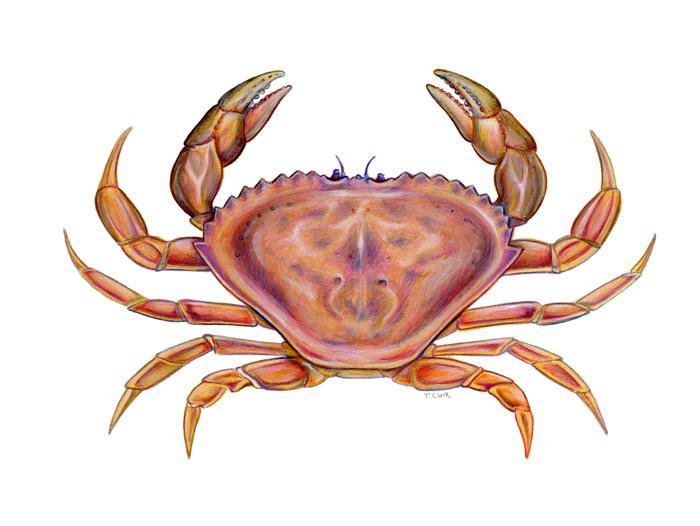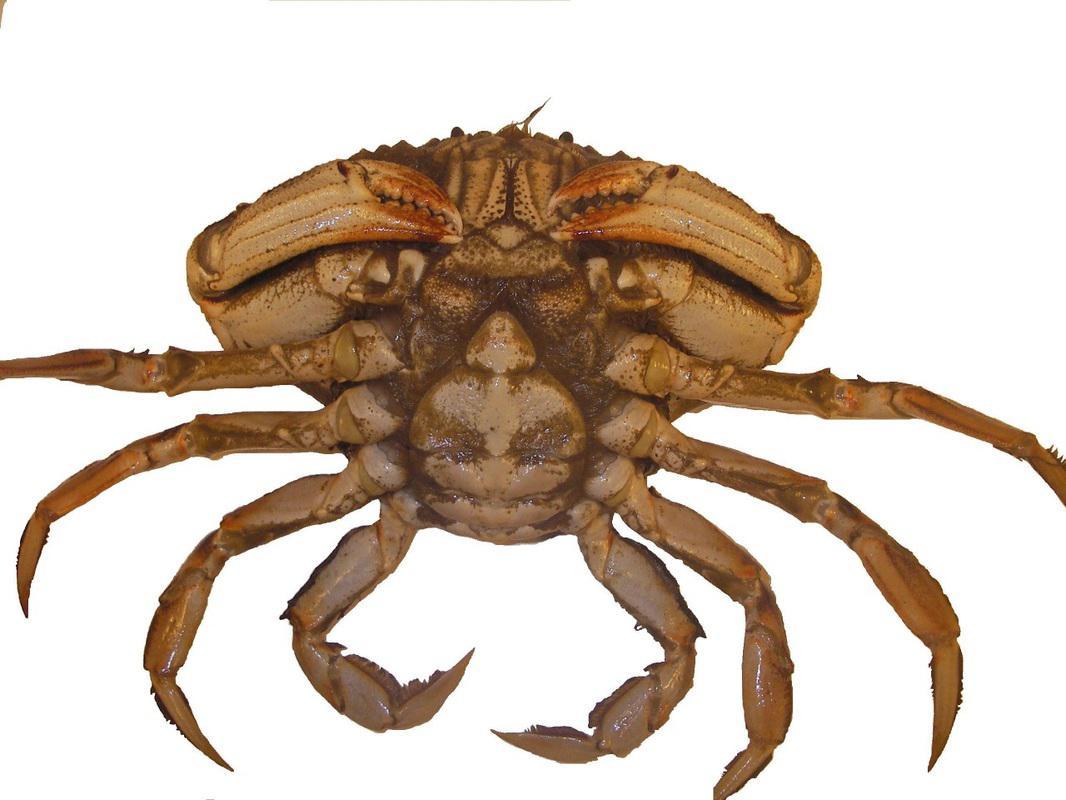The first image is the image on the left, the second image is the image on the right. Given the left and right images, does the statement "The left and right image contains the same number of crabs facing the same direction." hold true? Answer yes or no. No. The first image is the image on the left, the second image is the image on the right. For the images shown, is this caption "Both crabs are facing the same direction." true? Answer yes or no. No. 